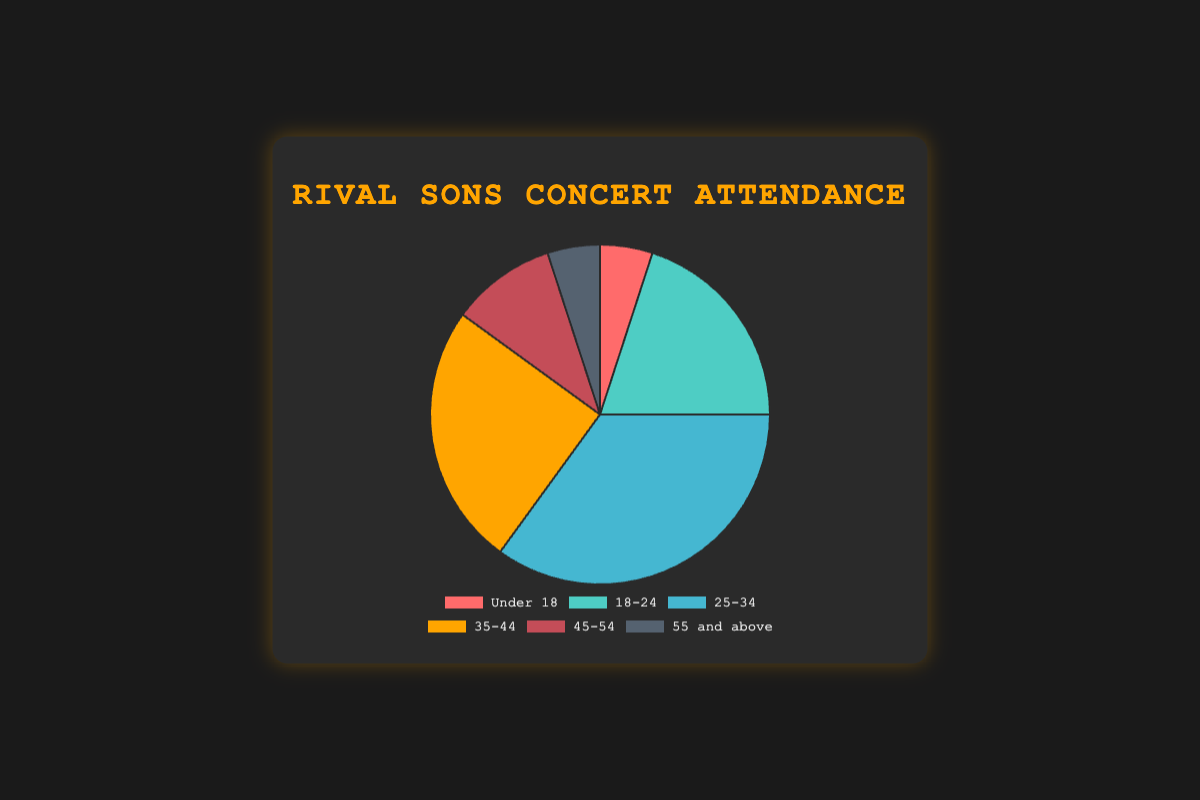What's the largest group of attendees by age? Look at the pie chart and locate the section with the largest area. The largest section represents the age group 25-34, which accounts for 35% of the attendees.
Answer: 25-34 What percentage of attendees are under 24 years old? Add the percentages of the age groups Under 18 and 18-24. It's 5% + 20% = 25%.
Answer: 25% Which age group has the same percentage of attendance as the Under 18 group? Both the Under 18 group and the 55 and above group have a 5% share of attendance.
Answer: 55 and above Compare the attendance percentages of the 25-34 and the 35-44 age groups. Which is higher, and by how much? The 25-34 age group has 35% while the 35-44 age group has 25%. The difference is 35% - 25% = 10%.
Answer: 25-34 by 10% What is the combined percentage of attendees aged 35 and older? Add the percentages of the age groups 35-44, 45-54, and 55 and above. It's 25% + 10% + 5% = 40%.
Answer: 40% Which color represents the age group of 18-24 years old? Look at the color corresponding to the 18-24 age group in the legend, which is a shade of green.
Answer: Green How do the percentages of the 18-24 age group and 45-54 age group compare? The 18-24 age group has 20% while the 45-54 age group has 10%. The 18-24 group is double the 45-54 group.
Answer: 18-24 is double What's the sum of the attendance percentages of all age groups under 35? Add the percentages of age groups Under 18, 18-24, and 25-34. It's 5% + 20% + 35% = 60%.
Answer: 60% If you combine the oldest and youngest age groups, what percentage of the attendees do they represent? Add the percentages of the Under 18 and 55 and above age groups. It's 5% + 5% = 10%.
Answer: 10% 